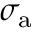Convert formula to latex. <formula><loc_0><loc_0><loc_500><loc_500>\sigma _ { a }</formula> 